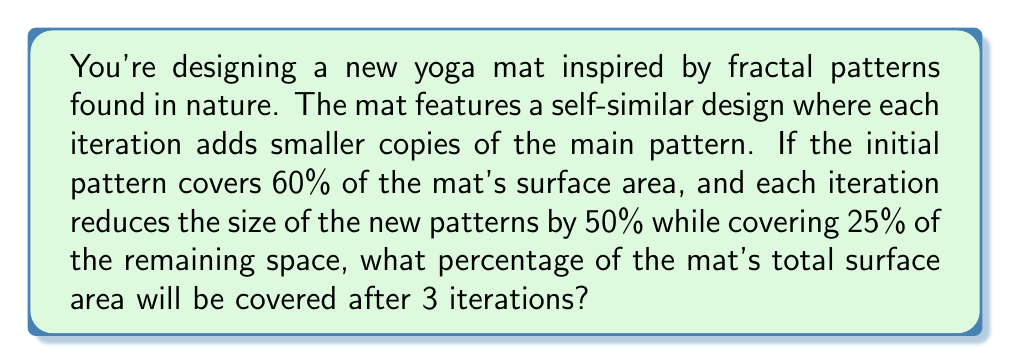Provide a solution to this math problem. Let's approach this step-by-step:

1) Initial coverage:
   $60\%$ of the mat is covered initially.

2) Remaining space after initial coverage:
   $100\% - 60\% = 40\%$ of the mat is uncovered.

3) First iteration:
   - New patterns cover $25\%$ of the remaining $40\%$
   - Area covered in first iteration: $40\% \times 25\% = 10\%$
   - Total coverage after first iteration: $60\% + 10\% = 70\%$

4) Second iteration:
   - Remaining space: $100\% - 70\% = 30\%$
   - New patterns cover $25\%$ of the remaining $30\%$
   - Area covered in second iteration: $30\% \times 25\% = 7.5\%$
   - Total coverage after second iteration: $70\% + 7.5\% = 77.5\%$

5) Third iteration:
   - Remaining space: $100\% - 77.5\% = 22.5\%$
   - New patterns cover $25\%$ of the remaining $22.5\%$
   - Area covered in third iteration: $22.5\% \times 25\% = 5.625\%$
   - Total coverage after third iteration: $77.5\% + 5.625\% = 83.125\%$

Therefore, after 3 iterations, $83.125\%$ of the mat's total surface area will be covered by the fractal pattern.
Answer: 83.125% 